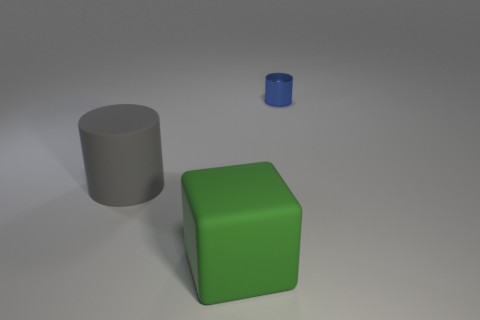Subtract all blocks. How many objects are left? 2 Subtract all brown cylinders. How many yellow cubes are left? 0 Subtract all tiny cylinders. Subtract all big gray cylinders. How many objects are left? 1 Add 3 big gray objects. How many big gray objects are left? 4 Add 3 tiny purple shiny cylinders. How many tiny purple shiny cylinders exist? 3 Add 1 tiny purple balls. How many objects exist? 4 Subtract all blue cylinders. How many cylinders are left? 1 Subtract 1 blue cylinders. How many objects are left? 2 Subtract all blue cylinders. Subtract all yellow spheres. How many cylinders are left? 1 